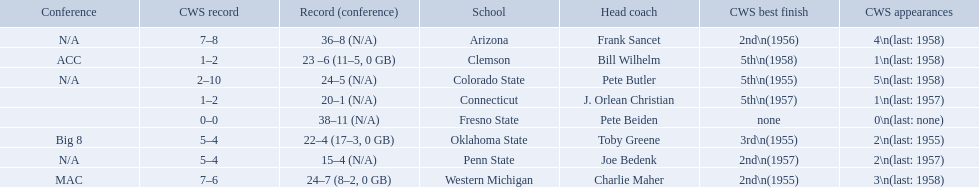What are the teams in the conference? Arizona, Clemson, Colorado State, Connecticut, Fresno State, Oklahoma State, Penn State, Western Michigan. Which have more than 16 wins? Arizona, Clemson, Colorado State, Connecticut, Fresno State, Oklahoma State, Western Michigan. Which had less than 16 wins? Penn State. 